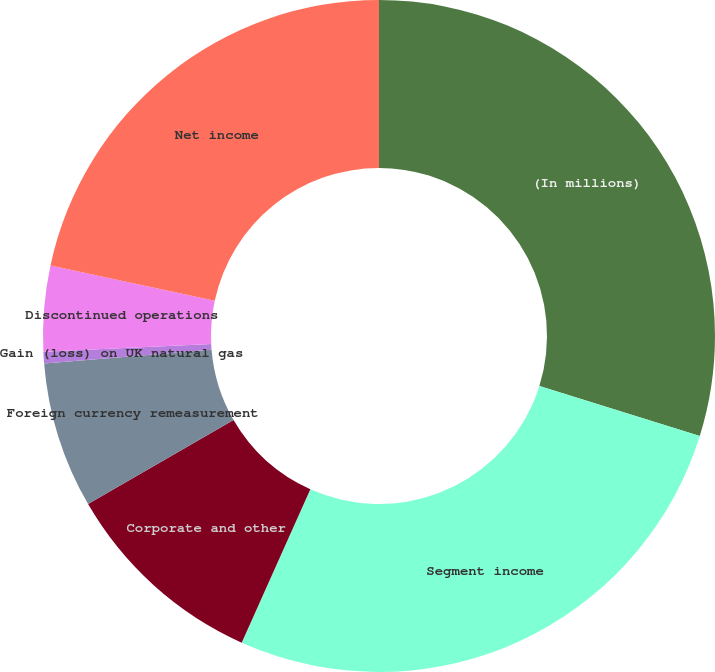<chart> <loc_0><loc_0><loc_500><loc_500><pie_chart><fcel>(In millions)<fcel>Segment income<fcel>Corporate and other<fcel>Foreign currency remeasurement<fcel>Gain (loss) on UK natural gas<fcel>Discontinued operations<fcel>Net income<nl><fcel>29.81%<fcel>26.89%<fcel>9.96%<fcel>7.04%<fcel>0.55%<fcel>4.12%<fcel>21.63%<nl></chart> 